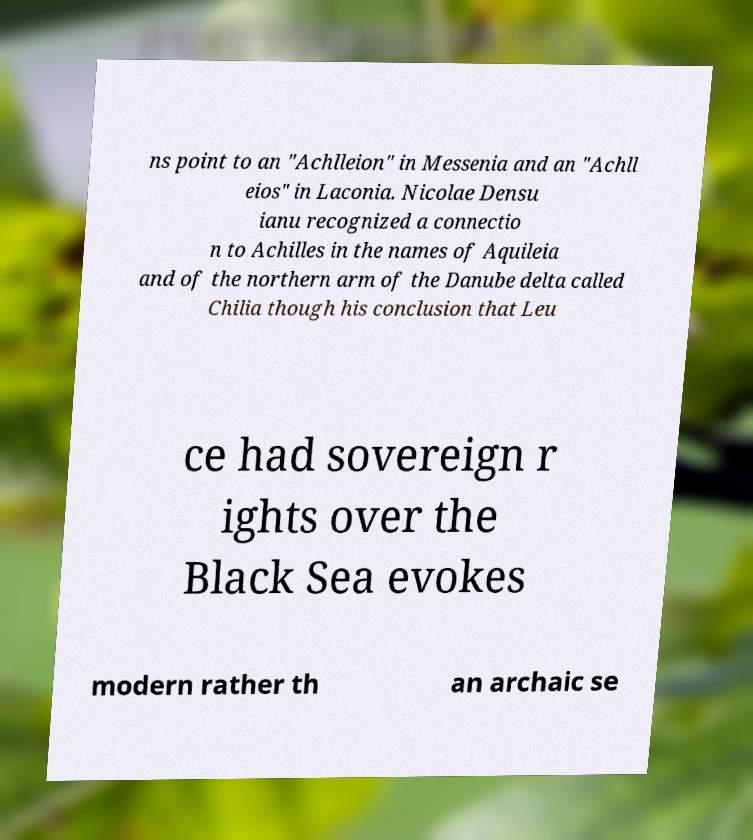For documentation purposes, I need the text within this image transcribed. Could you provide that? ns point to an "Achlleion" in Messenia and an "Achll eios" in Laconia. Nicolae Densu ianu recognized a connectio n to Achilles in the names of Aquileia and of the northern arm of the Danube delta called Chilia though his conclusion that Leu ce had sovereign r ights over the Black Sea evokes modern rather th an archaic se 